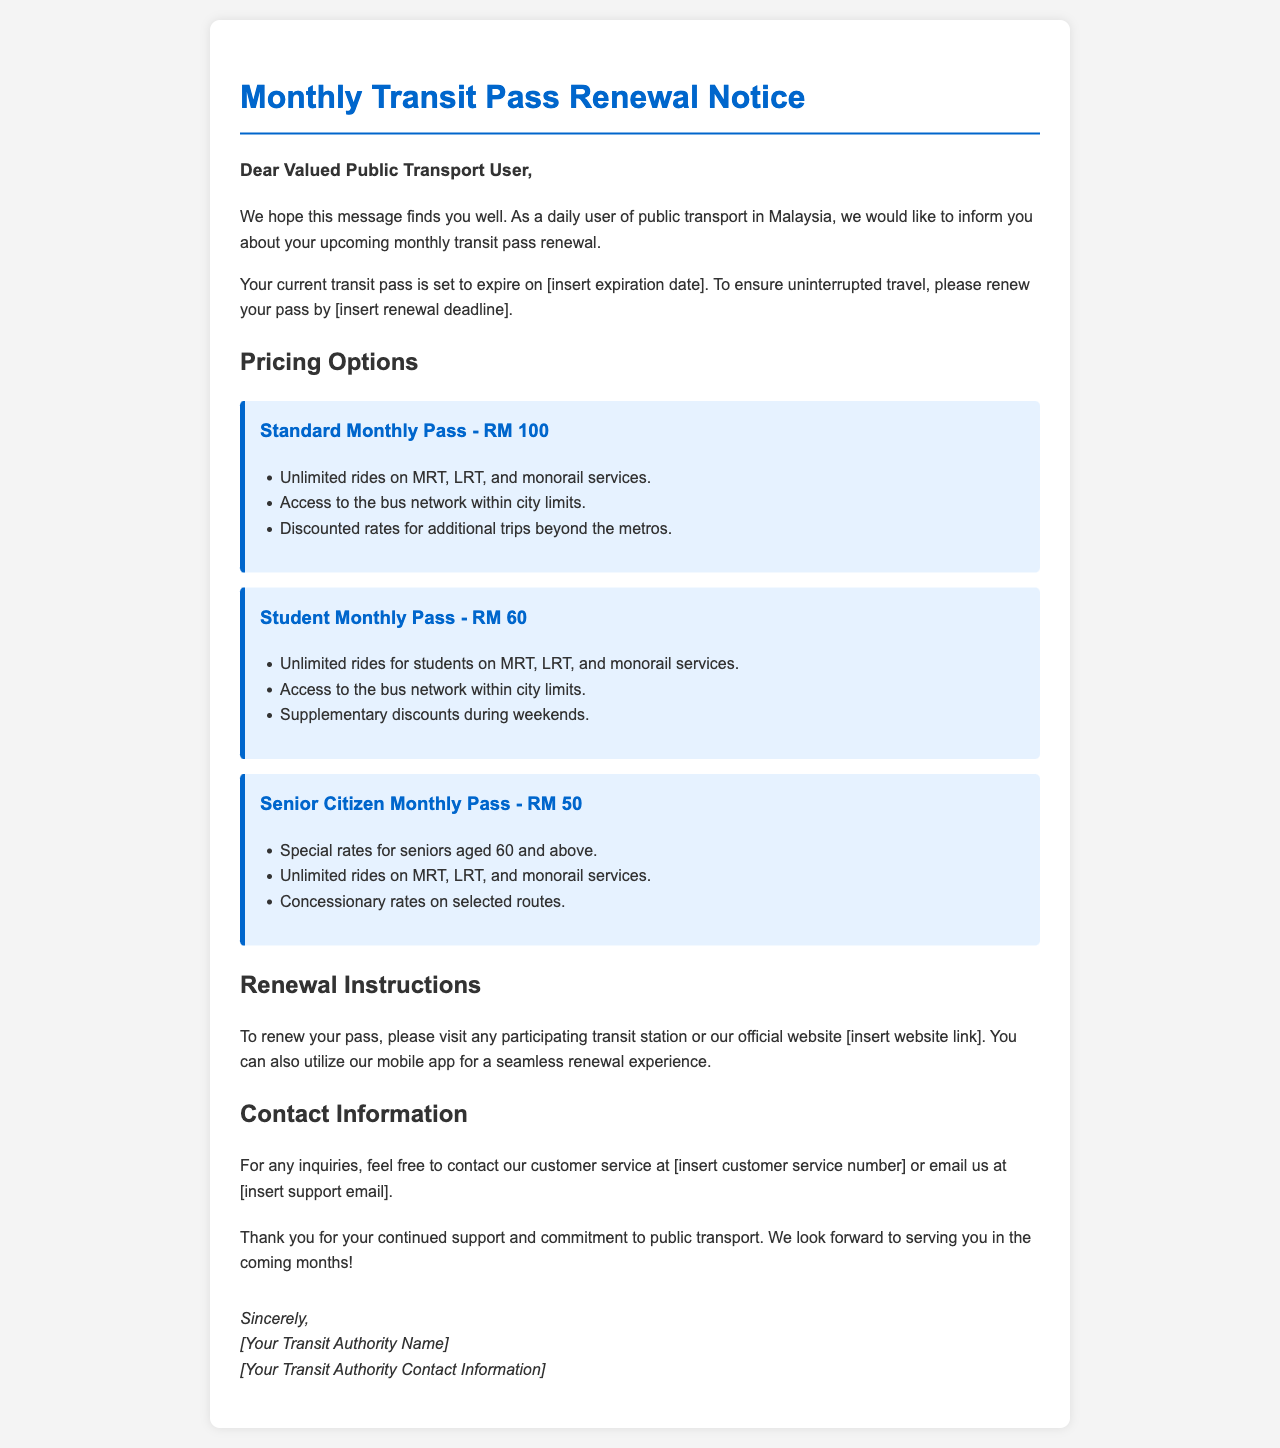What is the expiration date of the current transit pass? The document states that the expiration date will be mentioned as “[insert expiration date].”
Answer: [insert expiration date] What is the renewal deadline for the transit pass? The document specifies that the renewal deadline will be stated as “[insert renewal deadline].”
Answer: [insert renewal deadline] How much is the Standard Monthly Pass? The document lists the price for the Standard Monthly Pass.
Answer: RM 100 What are the benefits of the Senior Citizen Monthly Pass? The document lists benefits specific to the Senior Citizen Monthly Pass.
Answer: Special rates for seniors aged 60 and above, Unlimited rides on MRT, LRT, and monorail services, Concessionary rates on selected routes Where can I renew my transit pass? The document mentions where to renew the pass.
Answer: Any participating transit station, official website, mobile app What is the price of the Student Monthly Pass? The document provides the price for the Student Monthly Pass.
Answer: RM 60 What special discounts are available for the Student Monthly Pass? The document indicates the supplementary discounts for the Student Monthly Pass.
Answer: Supplementary discounts during weekends How can I contact customer service? The document details how to contact customer service.
Answer: [insert customer service number] or email [insert support email] What is the purpose of this document? The document is a notification regarding the renewal of a monthly transit pass.
Answer: Monthly Transit Pass Renewal Notice 